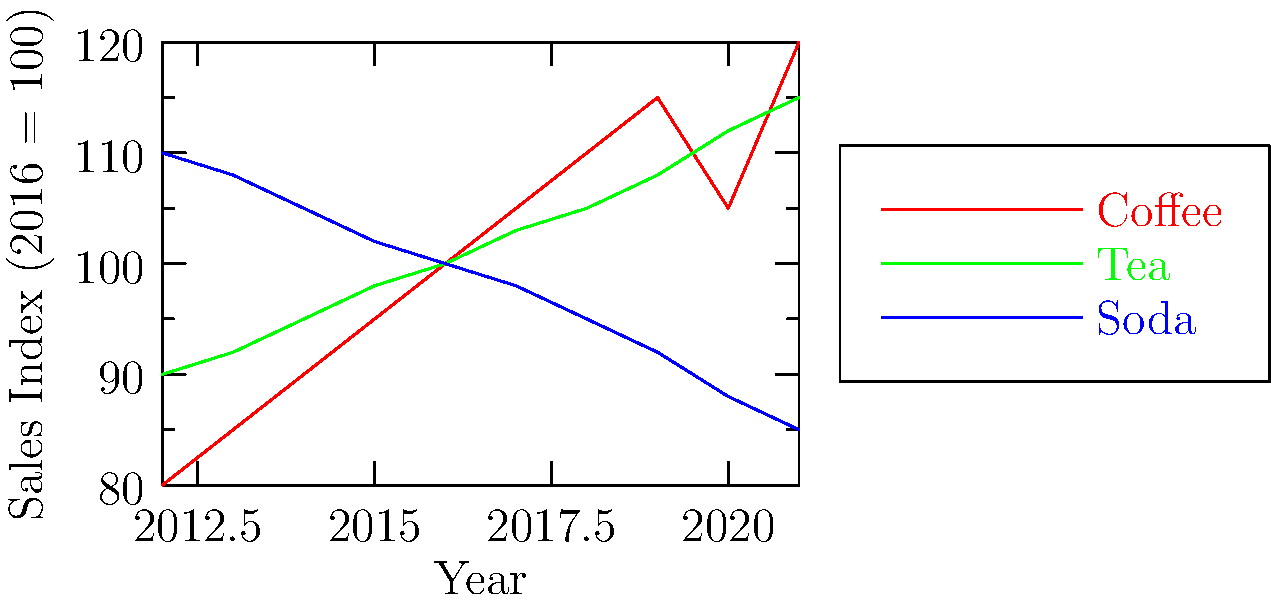Based on the line graph showing beverage sales trends over the past decade, which beverage category has shown the most consistent growth, and what factors might explain this trend? To answer this question, we need to analyze the trends for each beverage category:

1. Coffee:
   - Shows overall growth from 2012 to 2021
   - Experienced a dip in 2020 but recovered strongly in 2021
   - Growth is not entirely consistent due to the 2020 dip

2. Tea:
   - Demonstrates consistent year-over-year growth from 2012 to 2021
   - No significant dips or spikes in the trend line
   - Growth appears to be steady and uninterrupted

3. Soda:
   - Shows a consistent decline from 2012 to 2021
   - No growth observed in this category

Based on this analysis, tea has shown the most consistent growth over the past decade.

Factors that might explain this trend:

1. Health consciousness: Increasing awareness of health benefits associated with tea consumption
2. Variety: Growing availability of different tea flavors and types (green, black, herbal, etc.)
3. Cultural shifts: Rising popularity of tea-drinking cultures and traditions
4. Convenience: Increased availability of ready-to-drink tea products
5. Marketing: Effective promotion of tea as a healthier alternative to sugary drinks
6. Premiumization: Growth in the specialty and premium tea market segments
Answer: Tea, due to health trends, variety, and cultural shifts. 